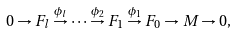Convert formula to latex. <formula><loc_0><loc_0><loc_500><loc_500>0 \to F _ { l } \stackrel { \phi _ { l } } { \to } \cdots \stackrel { \phi _ { 2 } } { \to } F _ { 1 } \stackrel { \phi _ { 1 } } { \to } F _ { 0 } \to M \to 0 ,</formula> 